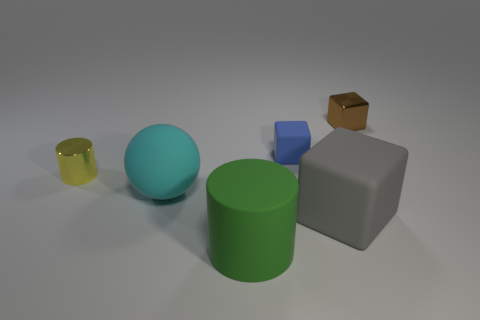What material is the cylinder in front of the cyan rubber sphere?
Ensure brevity in your answer.  Rubber. What is the shape of the metal object in front of the small block behind the rubber cube that is behind the tiny yellow thing?
Your answer should be very brief. Cylinder. Is the metal cylinder the same size as the green cylinder?
Make the answer very short. No. What number of objects are either large red matte cubes or matte objects behind the large sphere?
Your answer should be compact. 1. How many objects are tiny metallic things that are in front of the blue object or cylinders in front of the gray rubber object?
Provide a short and direct response. 2. Are there any small brown shiny cubes left of the large matte sphere?
Your answer should be compact. No. What color is the tiny metallic thing in front of the shiny thing that is behind the small metallic object to the left of the brown metal cube?
Offer a very short reply. Yellow. Is the shape of the small yellow metallic object the same as the cyan matte thing?
Keep it short and to the point. No. What is the color of the big cube that is the same material as the cyan thing?
Your response must be concise. Gray. How many objects are rubber objects in front of the gray object or green rubber cylinders?
Make the answer very short. 1. 